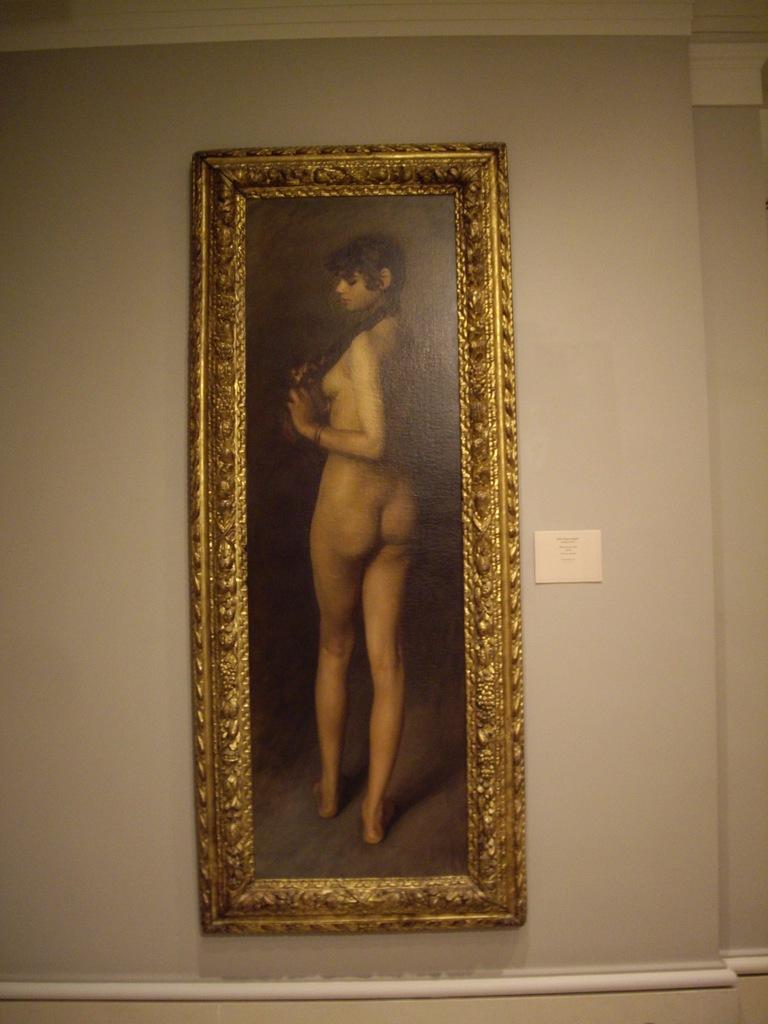What is attached to the wall in the image? There is a frame attached to the wall in the image. What can be seen inside the frame? There is a person standing in the frame. How many girls are sitting on the bed in the image? There is no bed or girls present in the image; it only features a frame with a person standing inside it. 